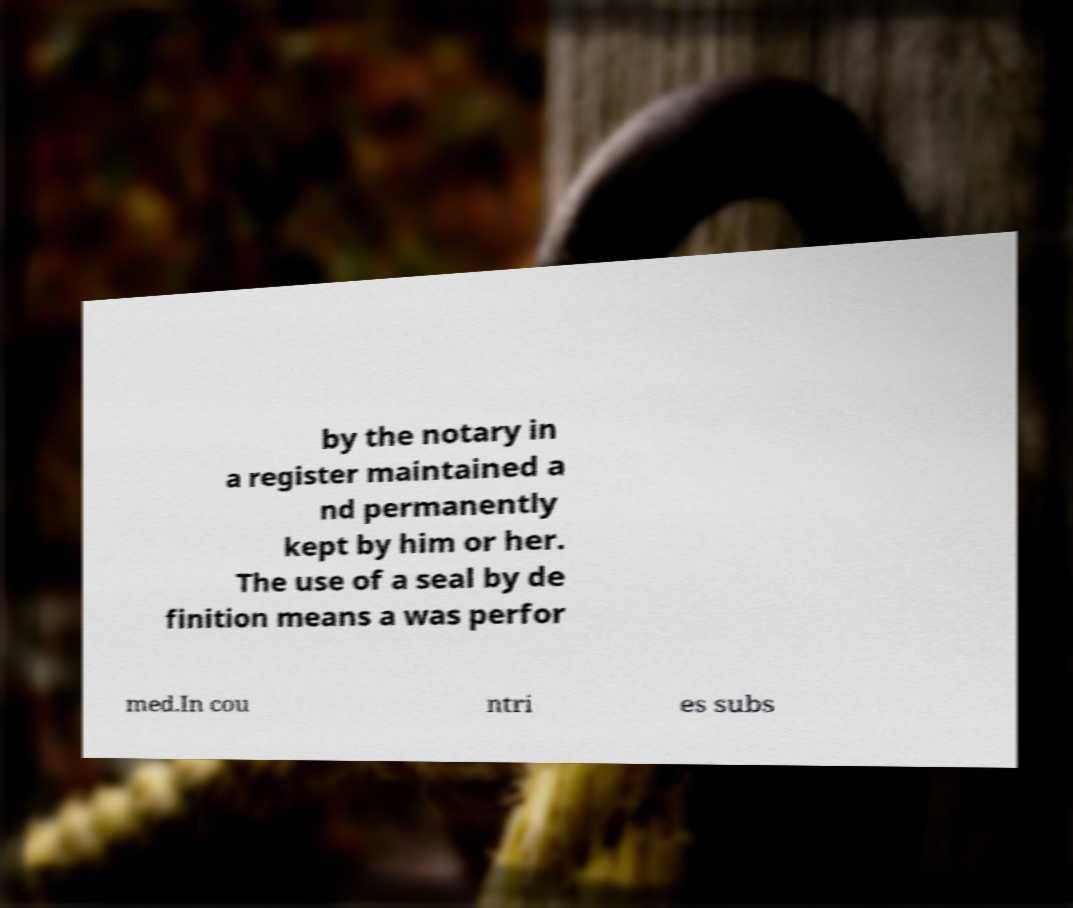Please read and relay the text visible in this image. What does it say? by the notary in a register maintained a nd permanently kept by him or her. The use of a seal by de finition means a was perfor med.In cou ntri es subs 